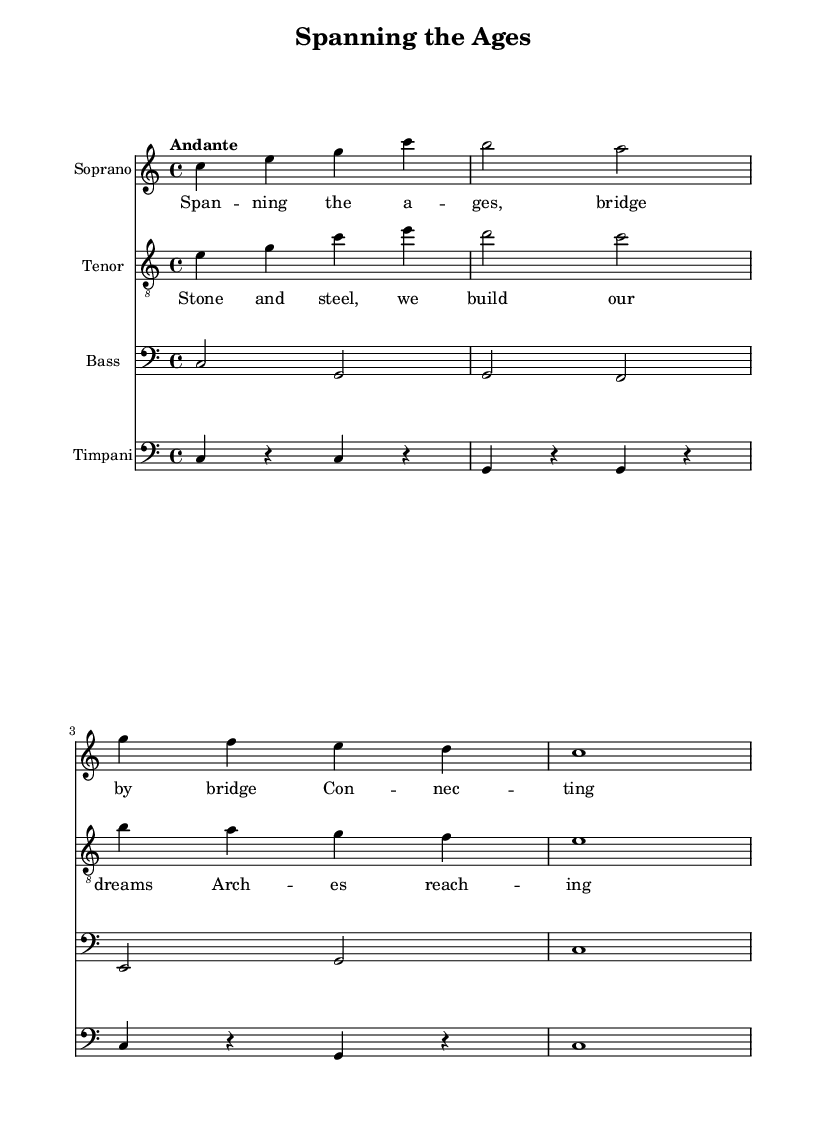What is the key signature of this music? The key signature is C major, which has no sharps or flats, indicated by the absence of any additional symbols next to the clef at the beginning of the staff.
Answer: C major What is the time signature of this music? The time signature is 4/4, shown prominently at the beginning of the score, indicating four beats per measure.
Answer: 4/4 What is the tempo marking of this piece? The tempo marking is "Andante," which is written above the staff and indicates a moderate walking pace for the performance.
Answer: Andante How many measures are in the soprano part? The soprano part consists of four measures, which can be counted by looking at the number of vertical bar lines dividing the musical staff.
Answer: Four What is the lyric theme of the soprano? The lyric theme of the soprano reflects the construction and connection of bridges throughout history, focusing on continuity and progress. This can be inferred from the words in the lyrics provided beneath the soprano part.
Answer: Connecting shores through time What instruments are featured in this opera? The instruments featured are Soprano, Tenor, Bass, and Timpani, clearly labeled at the beginning of each staff in the score.
Answer: Soprano, Tenor, Bass, Timpani Which vocal part's melody ascends in the first line? The melody in the soprano part ascends on the first line as it starts on C and moves upward to E and G.
Answer: Soprano 